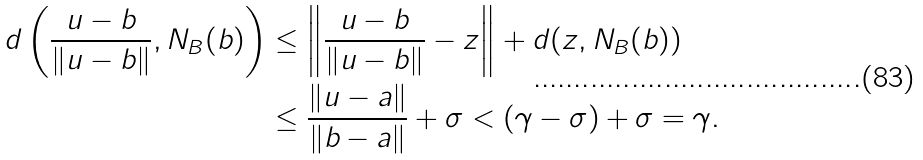<formula> <loc_0><loc_0><loc_500><loc_500>d \left ( \frac { u - b } { \| u - b \| } , N _ { B } ( b ) \right ) & \leq \left \| \frac { u - b } { \| u - b \| } - z \right \| + d ( z , N _ { B } ( b ) ) \\ & \leq \frac { \| u - a \| } { \| b - a \| } + \sigma < ( \gamma - \sigma ) + \sigma = \gamma .</formula> 